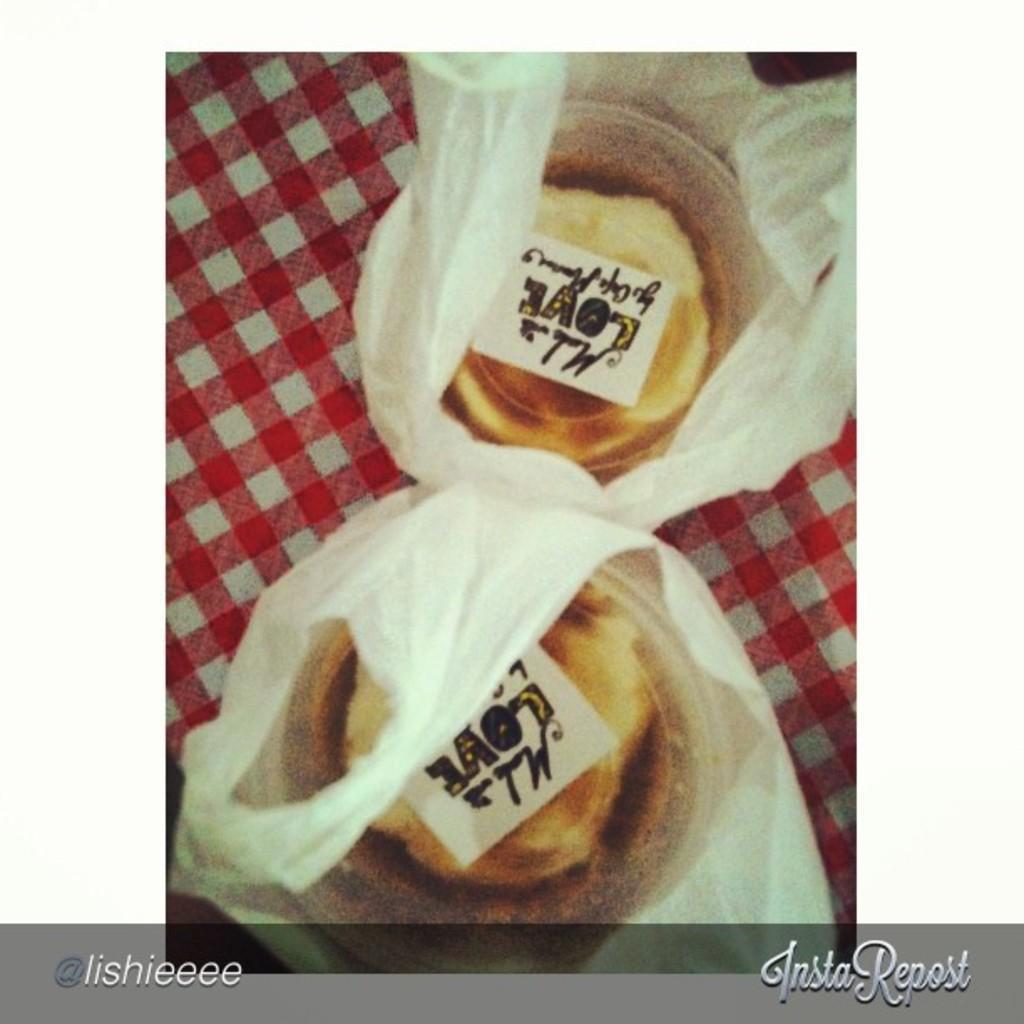How would you summarize this image in a sentence or two? In this picture I can see there is some food in the boxes and there are in the carry bag. 